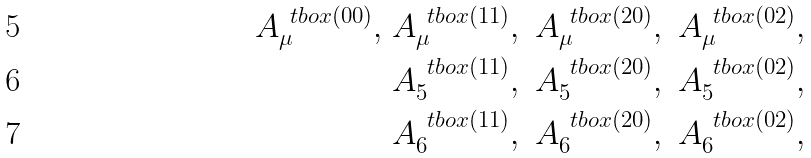Convert formula to latex. <formula><loc_0><loc_0><loc_500><loc_500>A ^ { \ t b o x { ( 0 0 ) } } _ { \mu } , \ & A ^ { \ t b o x { ( 1 1 ) } } _ { \mu } , \ A ^ { \ t b o x { ( 2 0 ) } } _ { \mu } , \ A ^ { \ t b o x { ( 0 2 ) } } _ { \mu } , \\ & A ^ { \ t b o x { ( 1 1 ) } } _ { 5 } , \ A ^ { \ t b o x { ( 2 0 ) } } _ { 5 } , \ A ^ { \ t b o x { ( 0 2 ) } } _ { 5 } , \\ & A ^ { \ t b o x { ( 1 1 ) } } _ { 6 } , \ A ^ { \ t b o x { ( 2 0 ) } } _ { 6 } , \ A ^ { \ t b o x { ( 0 2 ) } } _ { 6 } ,</formula> 